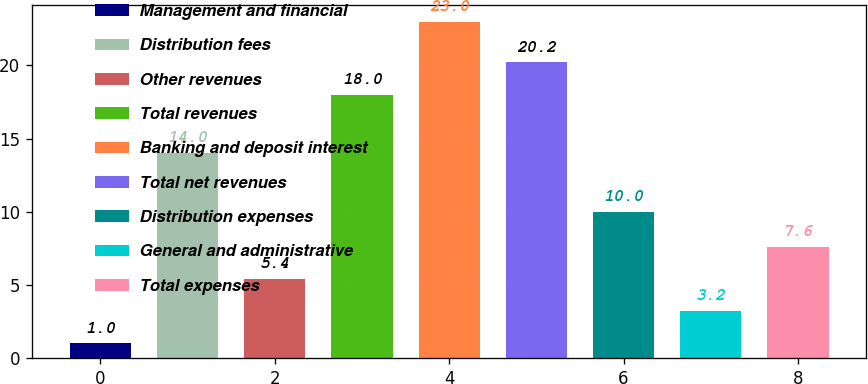Convert chart to OTSL. <chart><loc_0><loc_0><loc_500><loc_500><bar_chart><fcel>Management and financial<fcel>Distribution fees<fcel>Other revenues<fcel>Total revenues<fcel>Banking and deposit interest<fcel>Total net revenues<fcel>Distribution expenses<fcel>General and administrative<fcel>Total expenses<nl><fcel>1<fcel>14<fcel>5.4<fcel>18<fcel>23<fcel>20.2<fcel>10<fcel>3.2<fcel>7.6<nl></chart> 